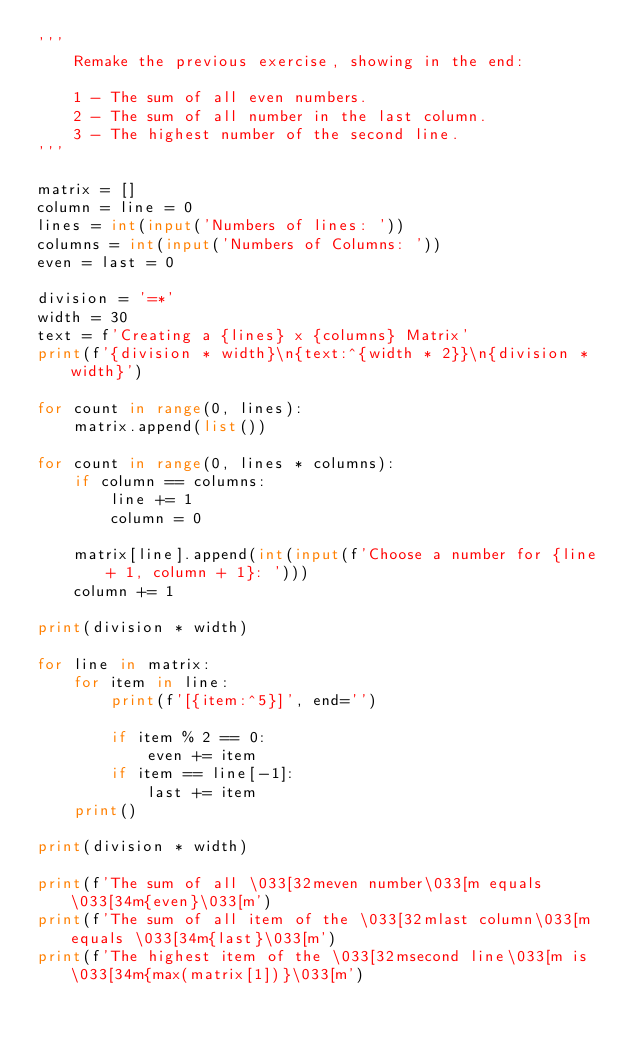<code> <loc_0><loc_0><loc_500><loc_500><_Python_>'''
    Remake the previous exercise, showing in the end:

    1 - The sum of all even numbers.
    2 - The sum of all number in the last column.
    3 - The highest number of the second line.
'''

matrix = []
column = line = 0
lines = int(input('Numbers of lines: '))
columns = int(input('Numbers of Columns: '))
even = last = 0

division = '=*'
width = 30
text = f'Creating a {lines} x {columns} Matrix'
print(f'{division * width}\n{text:^{width * 2}}\n{division * width}')

for count in range(0, lines):
    matrix.append(list())

for count in range(0, lines * columns):
    if column == columns:
        line += 1
        column = 0

    matrix[line].append(int(input(f'Choose a number for {line + 1, column + 1}: ')))
    column += 1

print(division * width)

for line in matrix:
    for item in line:
        print(f'[{item:^5}]', end='')

        if item % 2 == 0:
            even += item
        if item == line[-1]:
            last += item
    print()

print(division * width)

print(f'The sum of all \033[32meven number\033[m equals \033[34m{even}\033[m')
print(f'The sum of all item of the \033[32mlast column\033[m equals \033[34m{last}\033[m')
print(f'The highest item of the \033[32msecond line\033[m is \033[34m{max(matrix[1])}\033[m')
</code> 